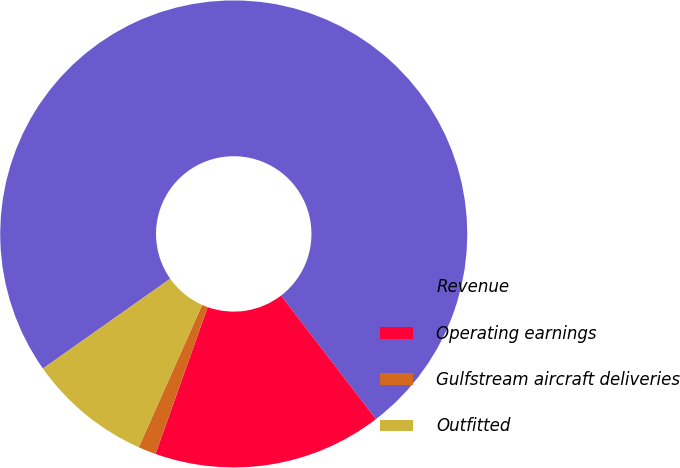Convert chart to OTSL. <chart><loc_0><loc_0><loc_500><loc_500><pie_chart><fcel>Revenue<fcel>Operating earnings<fcel>Gulfstream aircraft deliveries<fcel>Outfitted<nl><fcel>74.36%<fcel>15.86%<fcel>1.23%<fcel>8.55%<nl></chart> 